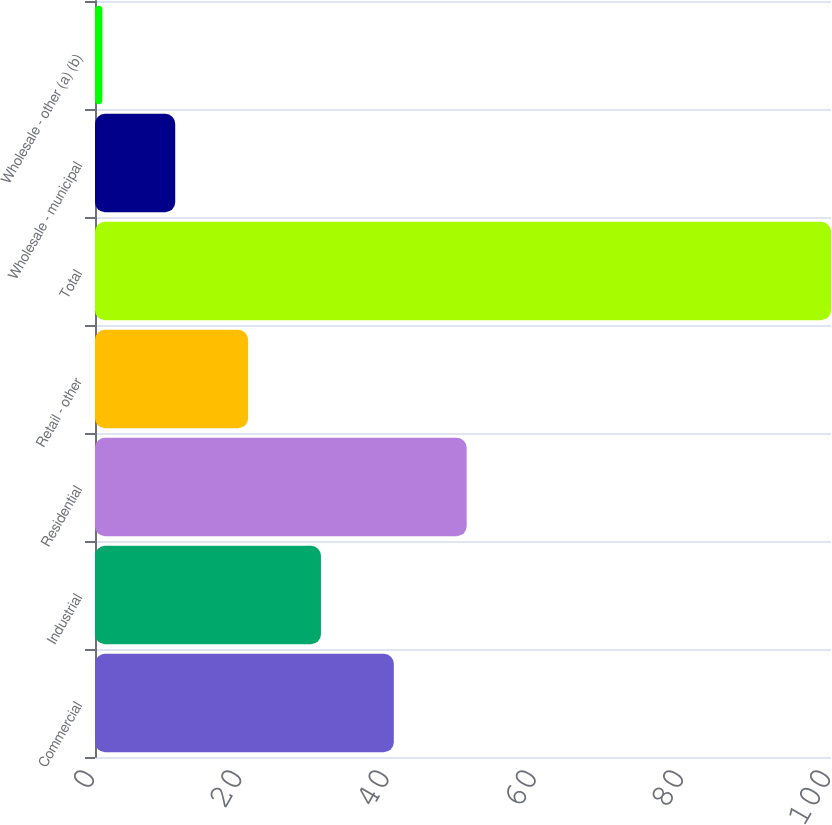<chart> <loc_0><loc_0><loc_500><loc_500><bar_chart><fcel>Commercial<fcel>Industrial<fcel>Residential<fcel>Retail - other<fcel>Total<fcel>Wholesale - municipal<fcel>Wholesale - other (a) (b)<nl><fcel>40.6<fcel>30.7<fcel>50.5<fcel>20.8<fcel>100<fcel>10.9<fcel>1<nl></chart> 